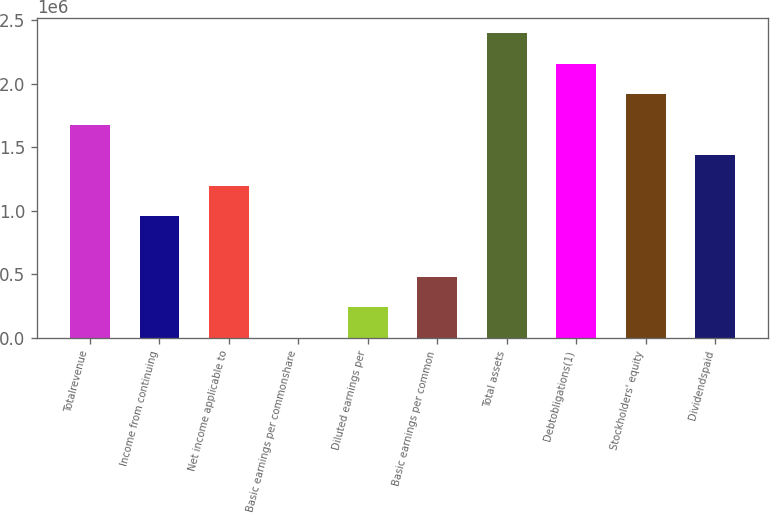Convert chart. <chart><loc_0><loc_0><loc_500><loc_500><bar_chart><fcel>Totalrevenue<fcel>Income from continuing<fcel>Net income applicable to<fcel>Basic earnings per commonshare<fcel>Diluted earnings per<fcel>Basic earnings per common<fcel>Total assets<fcel>Debtobligations(1)<fcel>Stockholders' equity<fcel>Dividendspaid<nl><fcel>1.6764e+06<fcel>957941<fcel>1.19743e+06<fcel>0.73<fcel>239486<fcel>478971<fcel>2.39485e+06<fcel>2.15537e+06<fcel>1.91588e+06<fcel>1.43691e+06<nl></chart> 